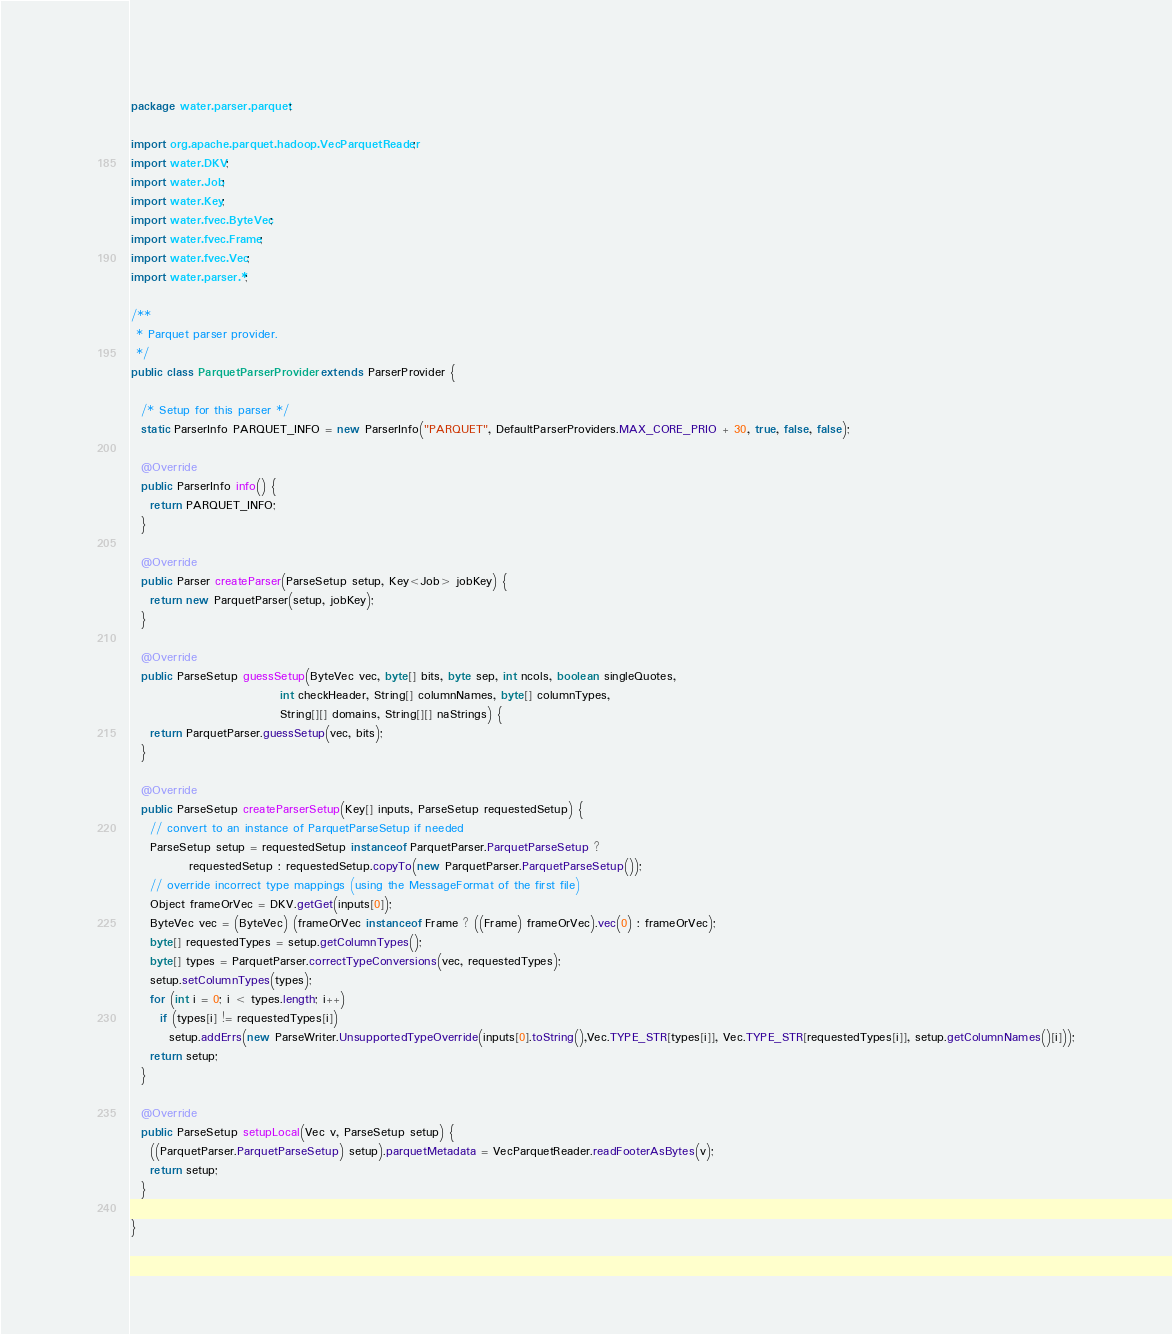Convert code to text. <code><loc_0><loc_0><loc_500><loc_500><_Java_>package water.parser.parquet;

import org.apache.parquet.hadoop.VecParquetReader;
import water.DKV;
import water.Job;
import water.Key;
import water.fvec.ByteVec;
import water.fvec.Frame;
import water.fvec.Vec;
import water.parser.*;

/**
 * Parquet parser provider.
 */
public class ParquetParserProvider extends ParserProvider {

  /* Setup for this parser */
  static ParserInfo PARQUET_INFO = new ParserInfo("PARQUET", DefaultParserProviders.MAX_CORE_PRIO + 30, true, false, false);

  @Override
  public ParserInfo info() {
    return PARQUET_INFO;
  }

  @Override
  public Parser createParser(ParseSetup setup, Key<Job> jobKey) {
    return new ParquetParser(setup, jobKey);
  }

  @Override
  public ParseSetup guessSetup(ByteVec vec, byte[] bits, byte sep, int ncols, boolean singleQuotes,
                               int checkHeader, String[] columnNames, byte[] columnTypes,
                               String[][] domains, String[][] naStrings) {
    return ParquetParser.guessSetup(vec, bits);
  }

  @Override
  public ParseSetup createParserSetup(Key[] inputs, ParseSetup requestedSetup) {
    // convert to an instance of ParquetParseSetup if needed
    ParseSetup setup = requestedSetup instanceof ParquetParser.ParquetParseSetup ?
            requestedSetup : requestedSetup.copyTo(new ParquetParser.ParquetParseSetup());
    // override incorrect type mappings (using the MessageFormat of the first file)
    Object frameOrVec = DKV.getGet(inputs[0]);
    ByteVec vec = (ByteVec) (frameOrVec instanceof Frame ? ((Frame) frameOrVec).vec(0) : frameOrVec);
    byte[] requestedTypes = setup.getColumnTypes();
    byte[] types = ParquetParser.correctTypeConversions(vec, requestedTypes);
    setup.setColumnTypes(types);
    for (int i = 0; i < types.length; i++)
      if (types[i] != requestedTypes[i])
        setup.addErrs(new ParseWriter.UnsupportedTypeOverride(inputs[0].toString(),Vec.TYPE_STR[types[i]], Vec.TYPE_STR[requestedTypes[i]], setup.getColumnNames()[i]));
    return setup;
  }

  @Override
  public ParseSetup setupLocal(Vec v, ParseSetup setup) {
    ((ParquetParser.ParquetParseSetup) setup).parquetMetadata = VecParquetReader.readFooterAsBytes(v);
    return setup;
  }

}
</code> 